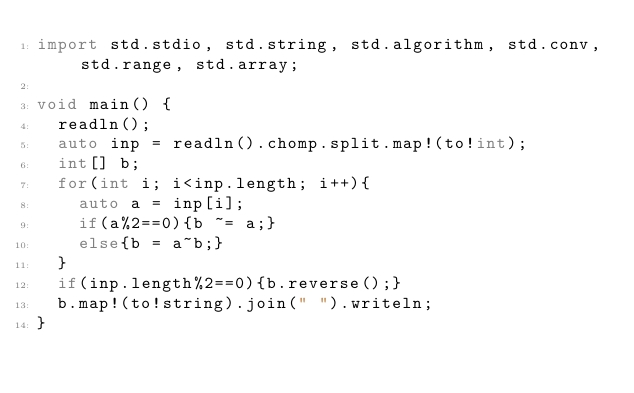<code> <loc_0><loc_0><loc_500><loc_500><_D_>import std.stdio, std.string, std.algorithm, std.conv, std.range, std.array;

void main() {
  readln();
  auto inp = readln().chomp.split.map!(to!int);
  int[] b;
  for(int i; i<inp.length; i++){
    auto a = inp[i];
    if(a%2==0){b ~= a;}
    else{b = a~b;}
  }
  if(inp.length%2==0){b.reverse();}
  b.map!(to!string).join(" ").writeln;
}</code> 